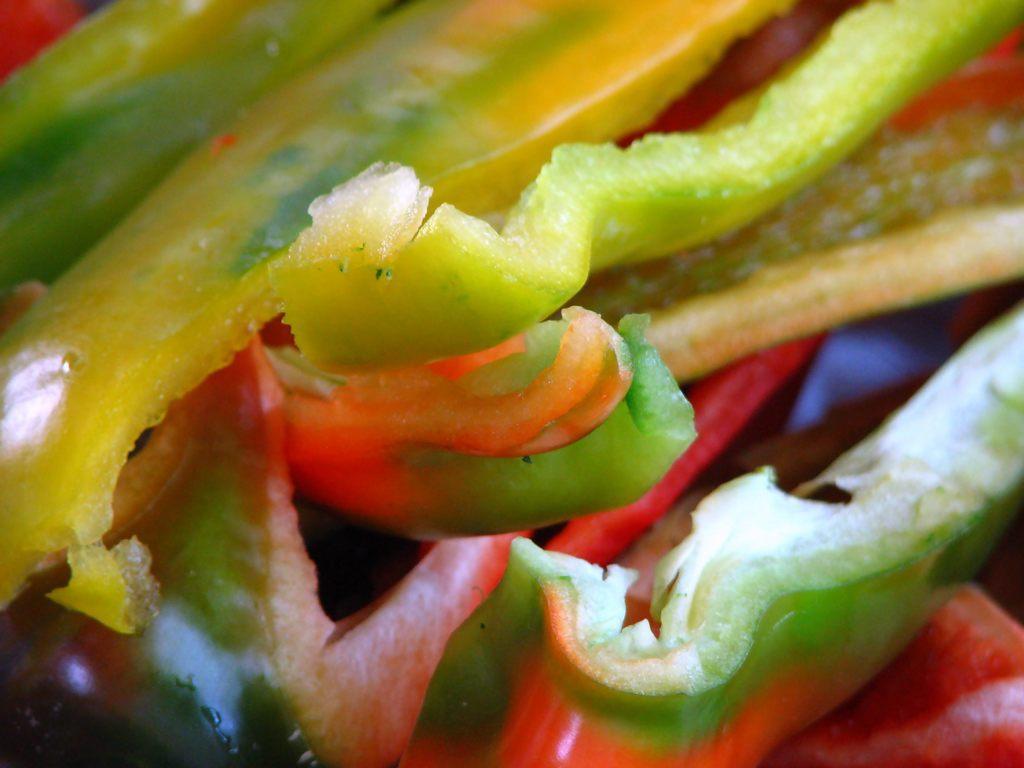How would you summarize this image in a sentence or two? In this image there are pieces of capsicum. 